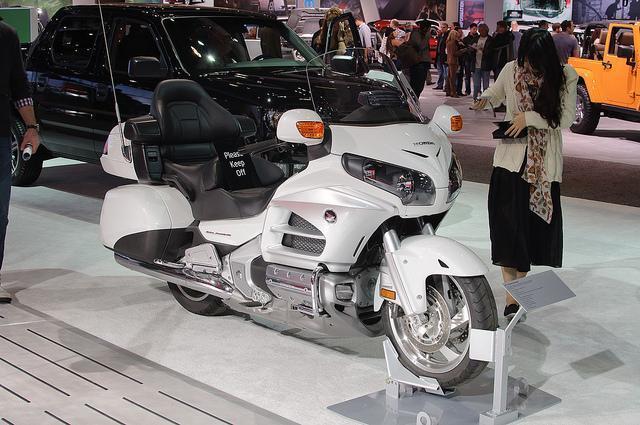How many yellow trucks are there?
Give a very brief answer. 1. How many trucks are in the photo?
Give a very brief answer. 2. How many people can you see?
Give a very brief answer. 2. How many train cars are behind the locomotive?
Give a very brief answer. 0. 